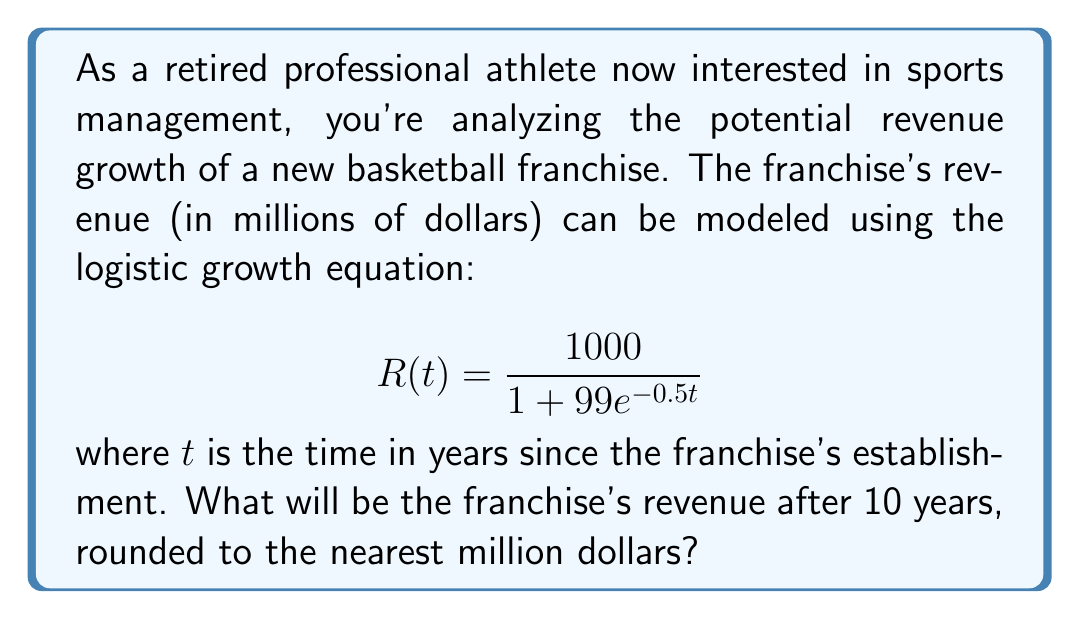Can you answer this question? To solve this problem, we'll follow these steps:

1. Understand the logistic growth model:
   The given equation is a logistic growth model where:
   - $1000$ is the carrying capacity (maximum revenue in millions)
   - $99$ is related to the initial condition
   - $0.5$ is the growth rate

2. Substitute $t = 10$ into the equation:

   $$R(10) = \frac{1000}{1 + 99e^{-0.5(10)}}$$

3. Simplify the exponent:

   $$R(10) = \frac{1000}{1 + 99e^{-5}}$$

4. Calculate $e^{-5}$ (you can use a calculator for this):

   $$e^{-5} \approx 0.00673795$$

5. Substitute this value:

   $$R(10) = \frac{1000}{1 + 99(0.00673795)}$$

6. Multiply in the denominator:

   $$R(10) = \frac{1000}{1 + 0.66705705}$$

7. Add in the denominator:

   $$R(10) = \frac{1000}{1.66705705}$$

8. Divide:

   $$R(10) \approx 599.86$$

9. Round to the nearest million:

   $$R(10) \approx 600$$

Therefore, after 10 years, the franchise's revenue will be approximately 600 million dollars.
Answer: $600 million 